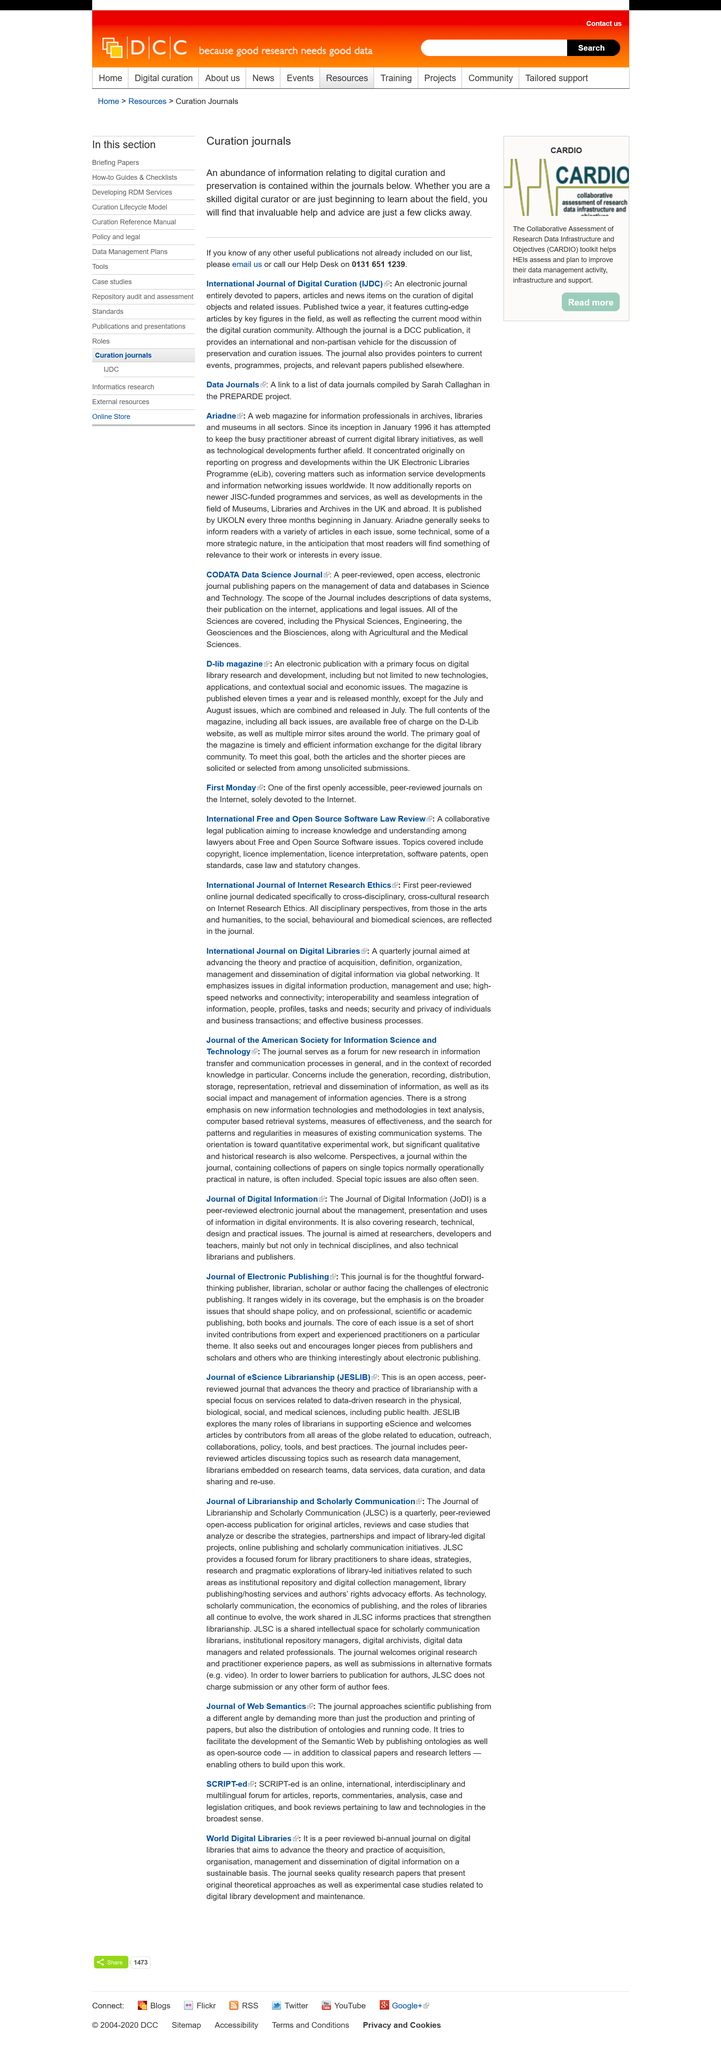Mention a couple of crucial points in this snapshot. International Journal of Digital Curation is an academic publication that focuses on the study of digital data preservation and management. IJDC is an electronic journal that publishes papers, articles, and news on the curation of digital objects and related issues. Curation journals are an accumulation of information pertaining to digital duration and preservation. 